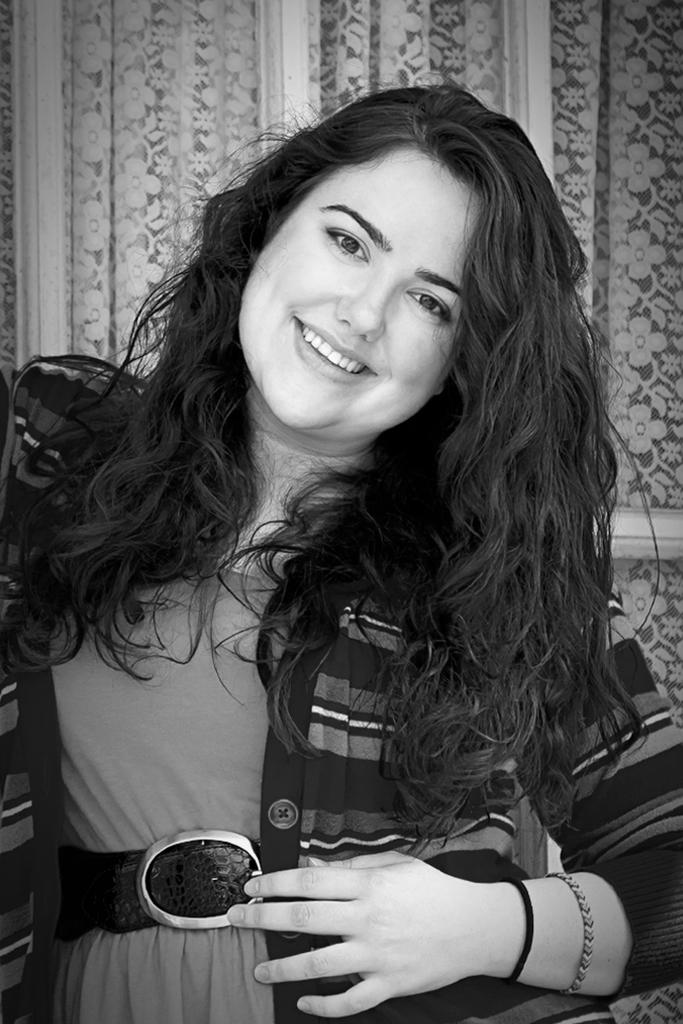Who is the main subject in the image? There is a lady in the image. What is the lady doing in the image? The lady is standing and smiling. What can be seen in the background of the image? There is a curtain in the background of the image. What type of lawyer is the lady in the image? There is no indication in the image that the lady is a lawyer, so it cannot be determined from the picture. 